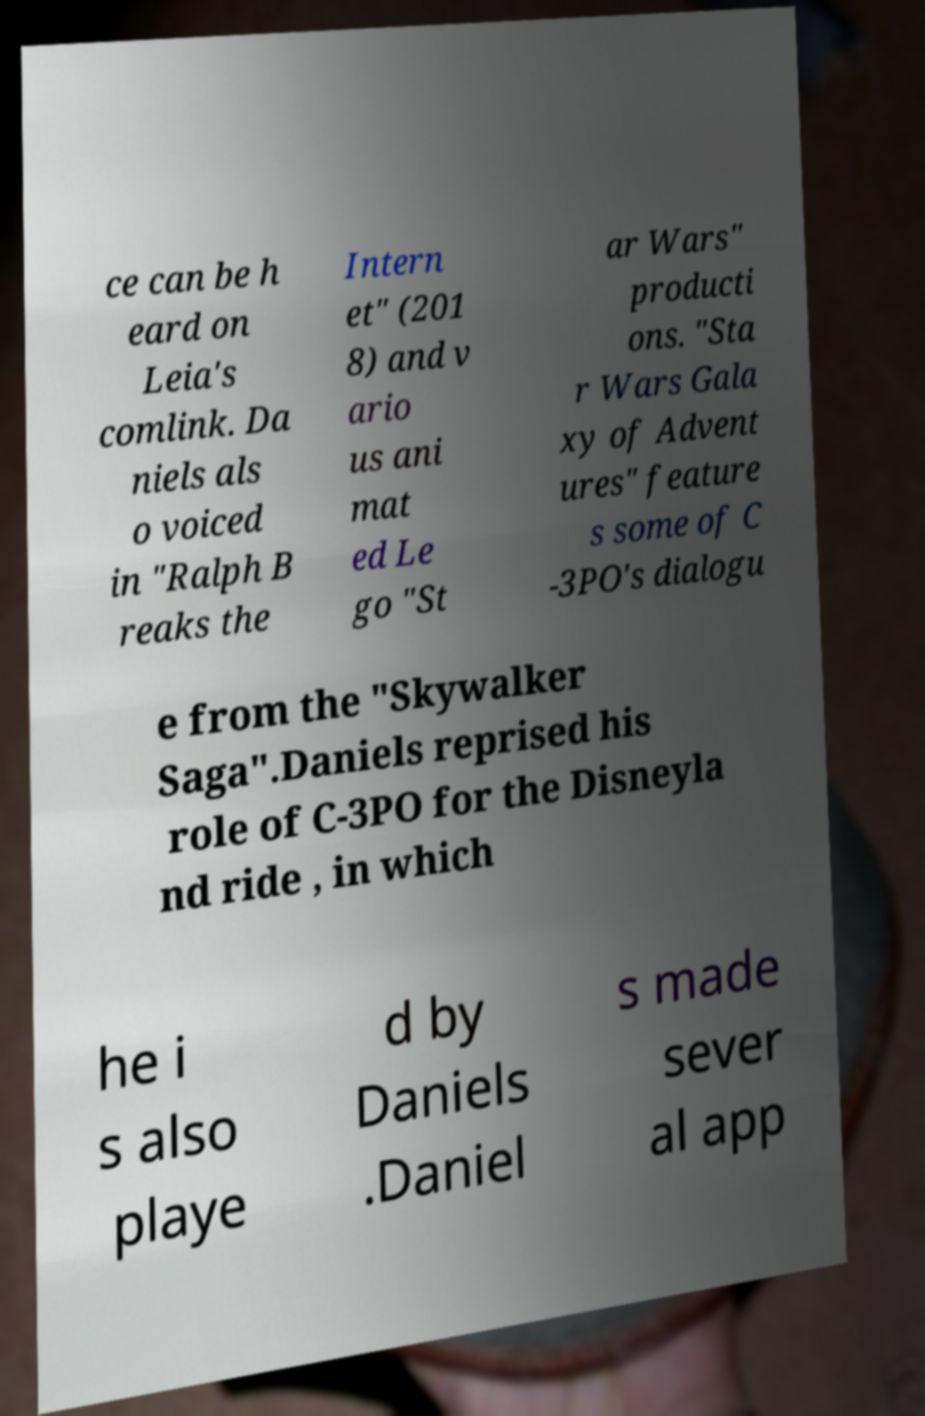There's text embedded in this image that I need extracted. Can you transcribe it verbatim? ce can be h eard on Leia's comlink. Da niels als o voiced in "Ralph B reaks the Intern et" (201 8) and v ario us ani mat ed Le go "St ar Wars" producti ons. "Sta r Wars Gala xy of Advent ures" feature s some of C -3PO's dialogu e from the "Skywalker Saga".Daniels reprised his role of C-3PO for the Disneyla nd ride , in which he i s also playe d by Daniels .Daniel s made sever al app 